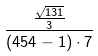Convert formula to latex. <formula><loc_0><loc_0><loc_500><loc_500>\frac { \frac { \sqrt { 1 3 1 } } { 3 } } { ( 4 5 4 - 1 ) \cdot 7 }</formula> 